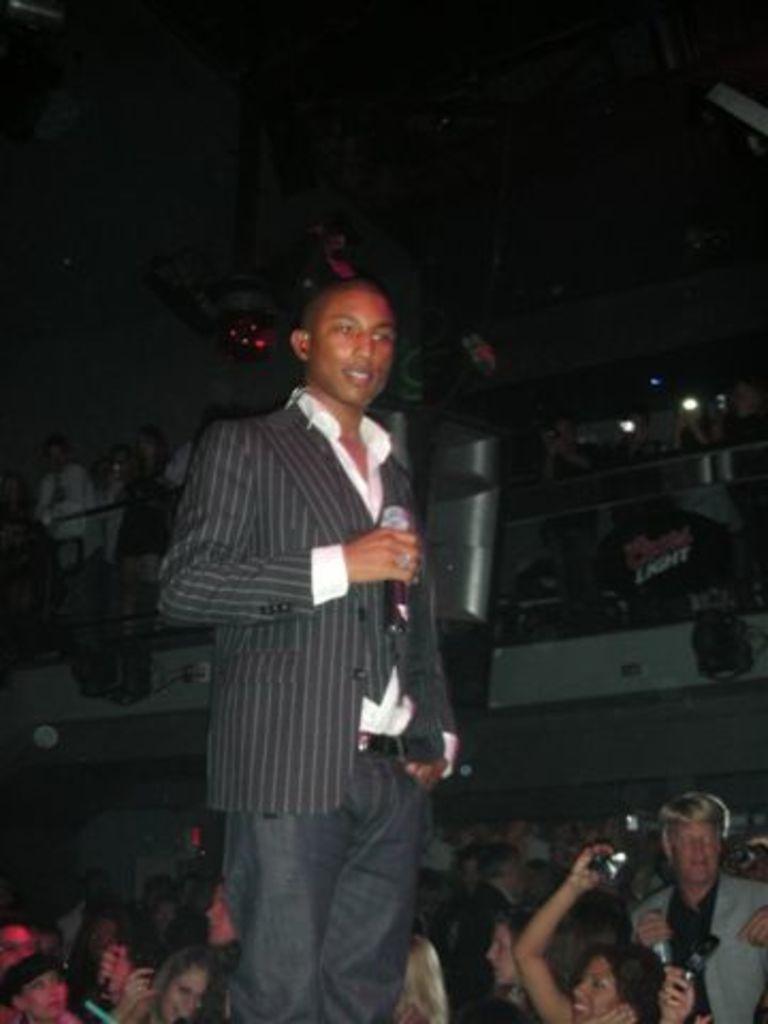In one or two sentences, can you explain what this image depicts? In this picture there is a man standing and holding the microphone. At the back there are group of people and there is a board and there is text on the board and there are objects on the wall. At the top there are objects. 